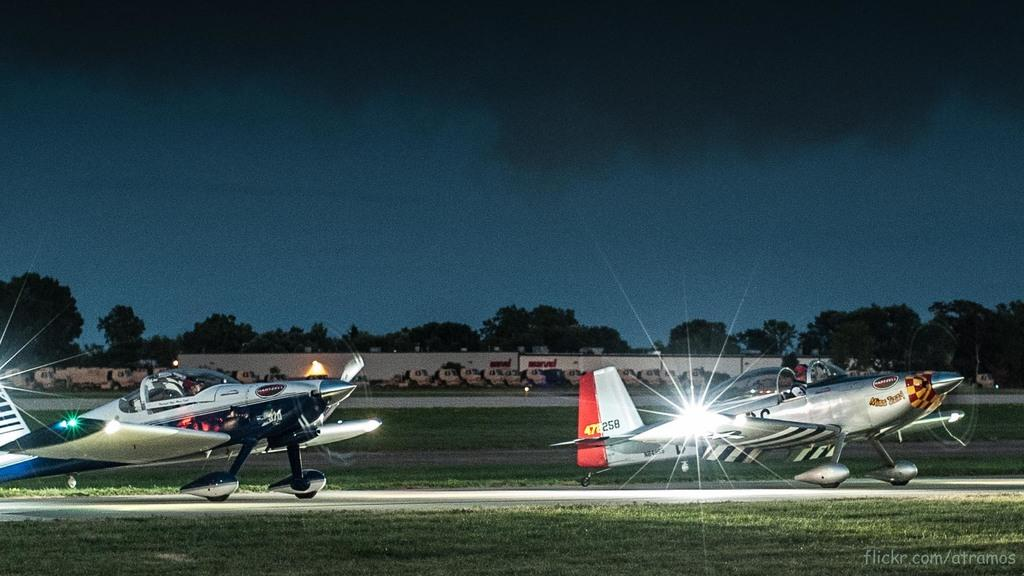What is the main subject of the image? The main subject of the image is two planes. Are there any people visible in the image? Yes, there are two people sitting inside one of the planes. What can be seen in the background of the image? Trees and the sky are visible in the background of the image. What type of flag is being waved by the cattle in the image? There are no cattle or flags present in the image; it features two planes and two people inside one of them. 